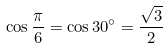<formula> <loc_0><loc_0><loc_500><loc_500>\cos { \frac { \pi } { 6 } } = \cos 3 0 ^ { \circ } = { \frac { \sqrt { 3 } } { 2 } }</formula> 